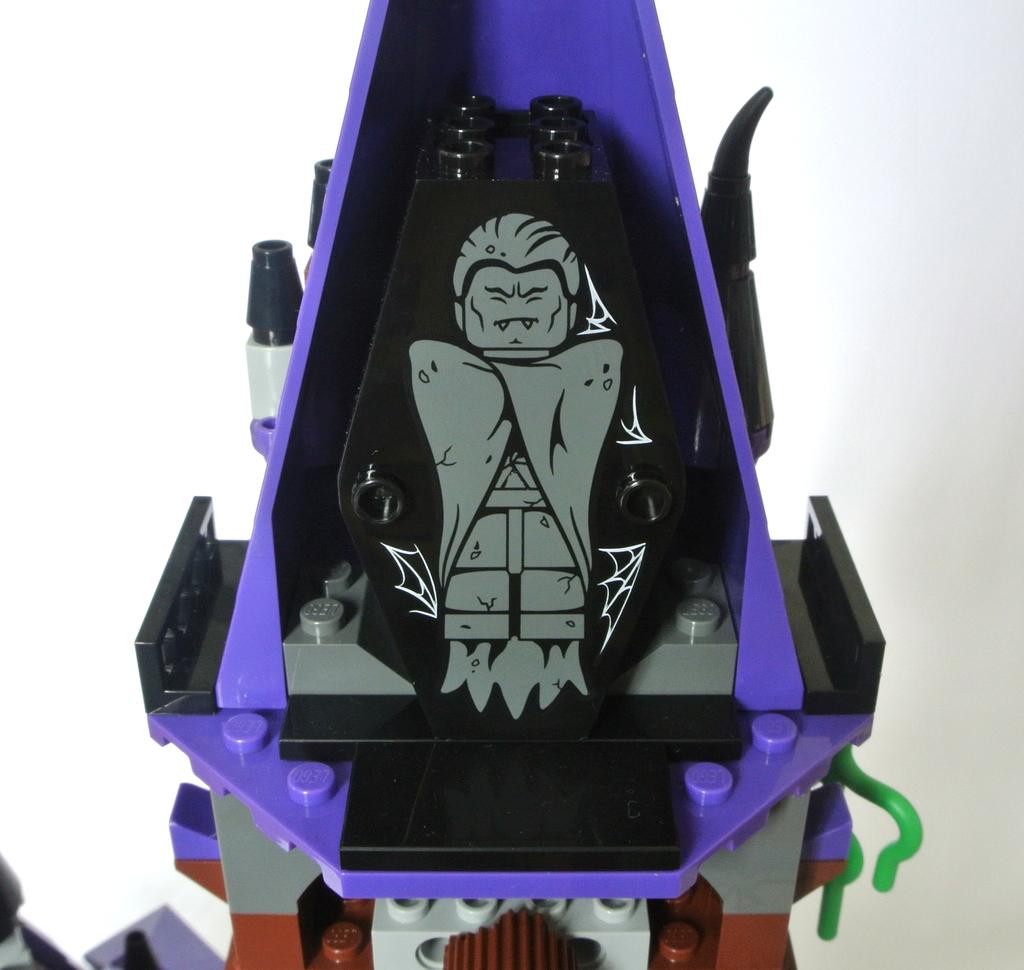What is the main subject of the image? The main subject of the image is an object that resembles a Lego toy. What can be seen in the background of the image? The background of the image is white. What type of zinc is present in the image? There is no zinc present in the image; it features an object that resembles a Lego toy. What type of fictional character is depicted in the image? There is no fictional character depicted in the image; it features an object that resembles a Lego toy. 